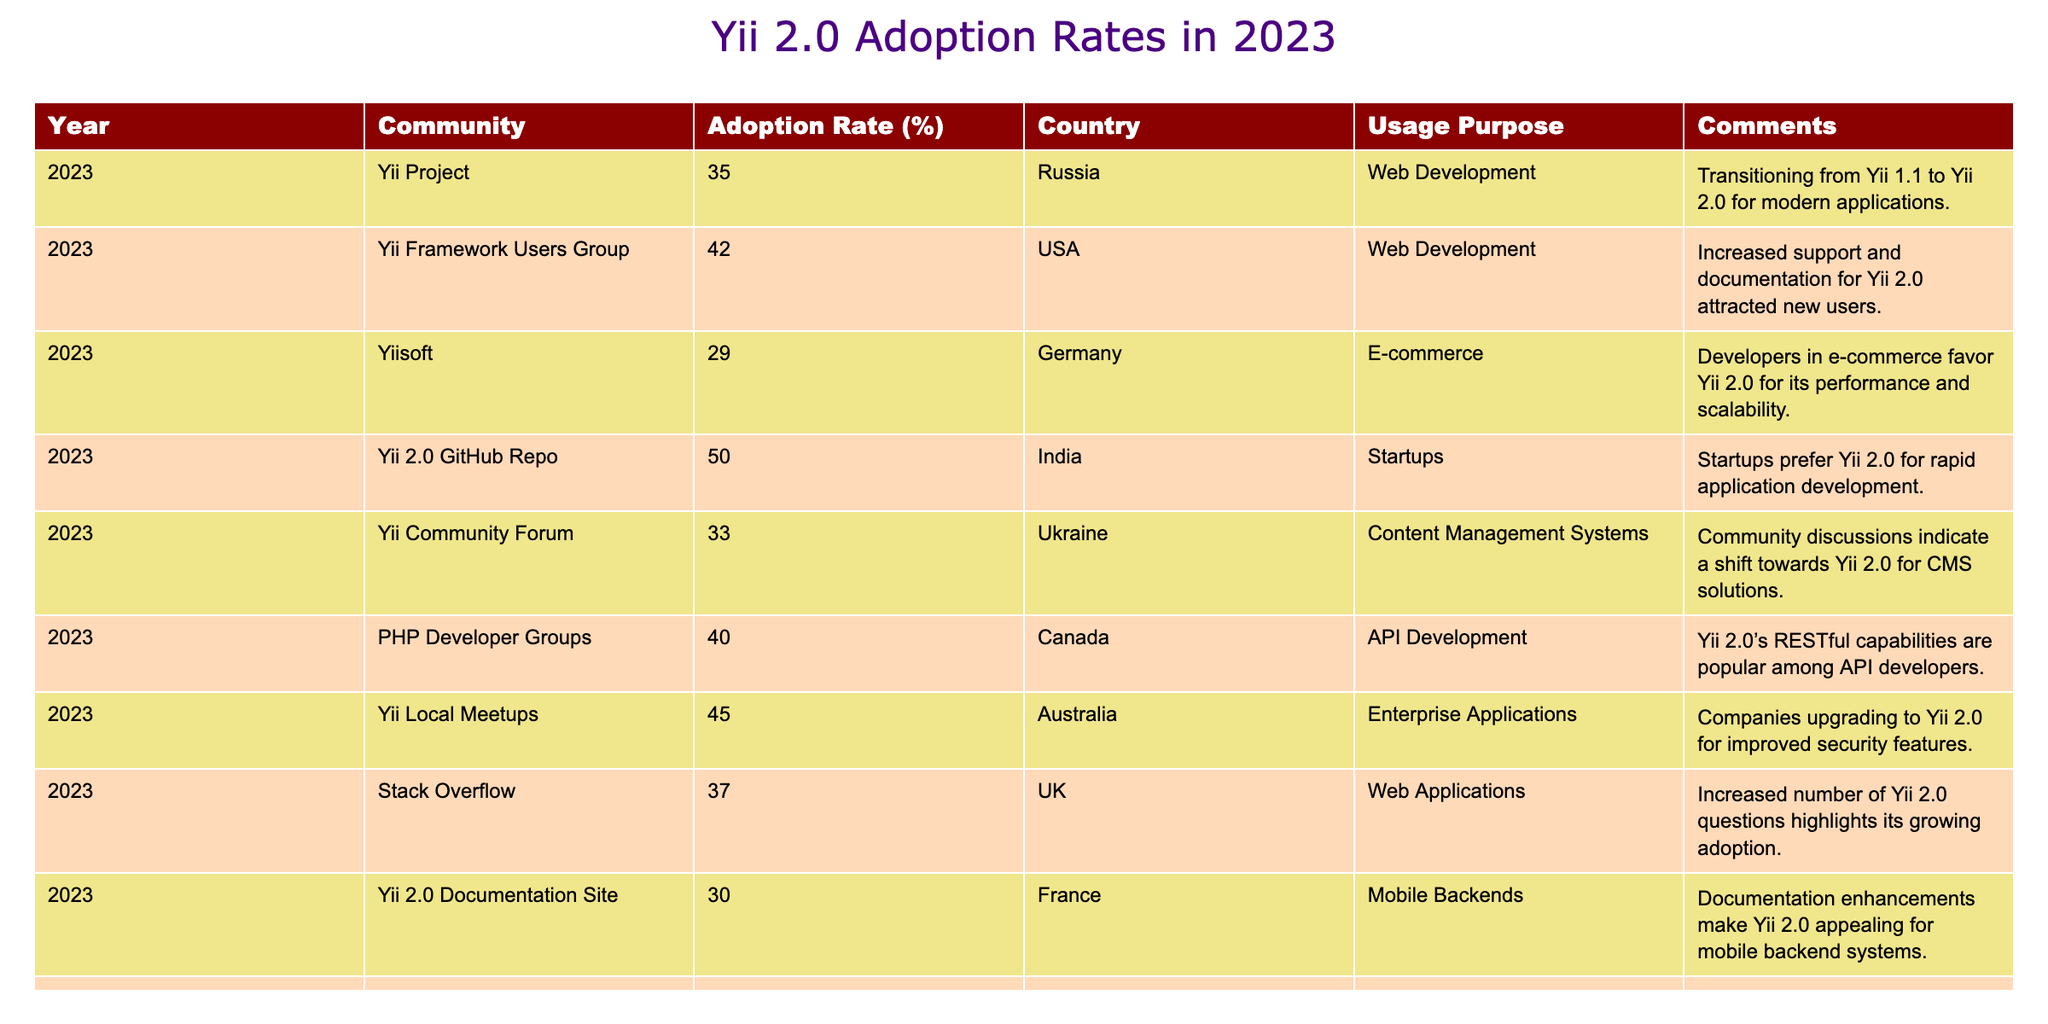What is the highest adoption rate for Yii 2.0 according to the table? The adoption rates for Yii 2.0 are provided for various communities. By examining the values, I can see that India has the highest adoption rate at 50%.
Answer: 50% What is the adoption rate for Yii 2.0 in Brazil? The adoption rate in Brazil is indicated in the table by the 'Freelance Developer Platforms' entry, which shows an adoption rate of 32%.
Answer: 32% Which community has an adoption rate of 29%? Upon checking the table, 'Yiisoft' is listed as the community with an adoption rate of 29%, which is specifically for Germany.
Answer: Yiisoft What is the average adoption rate for all the listed countries? To find the average, I will first sum the adoption rates: 35 + 42 + 29 + 50 + 33 + 40 + 45 + 37 + 30 + 32 equals 423. Then, dividing by the number of entries (10) gives an average of 42.3%.
Answer: 42.3% Is there a community where the adoption rate is greater than 40%? Analyzing the table, I can see that there are four communities with adoption rates over 40%: 'Yii 2.0 GitHub Repo' (50%), 'Yii Local Meetups' (45%), 'Yii Framework Users Group' (42%), and 'PHP Developer Groups' (40%). Therefore, the answer is yes.
Answer: Yes What is the adoption rate difference between the USA and Germany? The USA has an adoption rate of 42%, while Germany's is 29%. Therefore, the difference is 42 - 29 = 13%.
Answer: 13% Does the data indicate that the majority of communities have adoption rates below 40%? By checking the values in the table, I can identify that five communities have rates below 40% (35%, 29%, 33%, 30%, and 32%). Since there are ten total entries, this means more than half have rates below 40%. Hence, the statement is true.
Answer: Yes What is the second lowest adoption rate and which community does it belong to? The lowest adoption rate is 29% (Yiisoft), and the next lowest is 30% (Yii 2.0 Documentation Site). Therefore, the second lowest rate is 30% from the Yii 2.0 Documentation Site.
Answer: 30%, Yii 2.0 Documentation Site Which country has the lowest adoption rate for Yii 2.0? The table indicates that Germany has the lowest adoption rate at 29% according to the entry for 'Yiisoft.'
Answer: Germany 